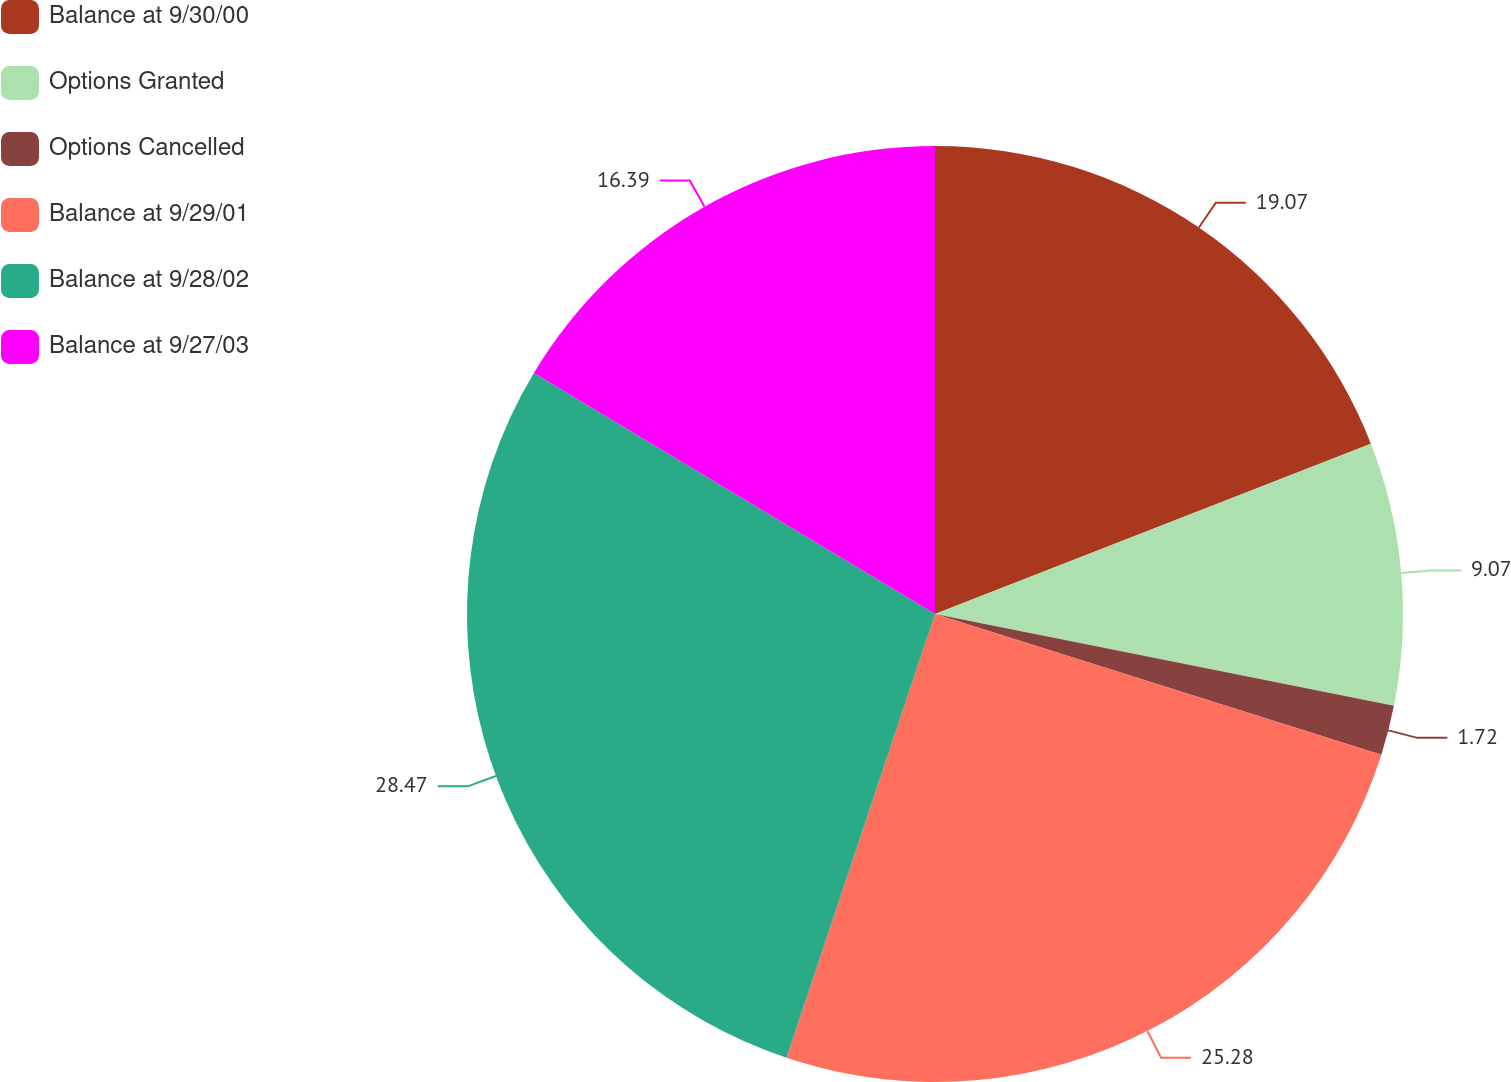<chart> <loc_0><loc_0><loc_500><loc_500><pie_chart><fcel>Balance at 9/30/00<fcel>Options Granted<fcel>Options Cancelled<fcel>Balance at 9/29/01<fcel>Balance at 9/28/02<fcel>Balance at 9/27/03<nl><fcel>19.07%<fcel>9.07%<fcel>1.72%<fcel>25.28%<fcel>28.47%<fcel>16.39%<nl></chart> 